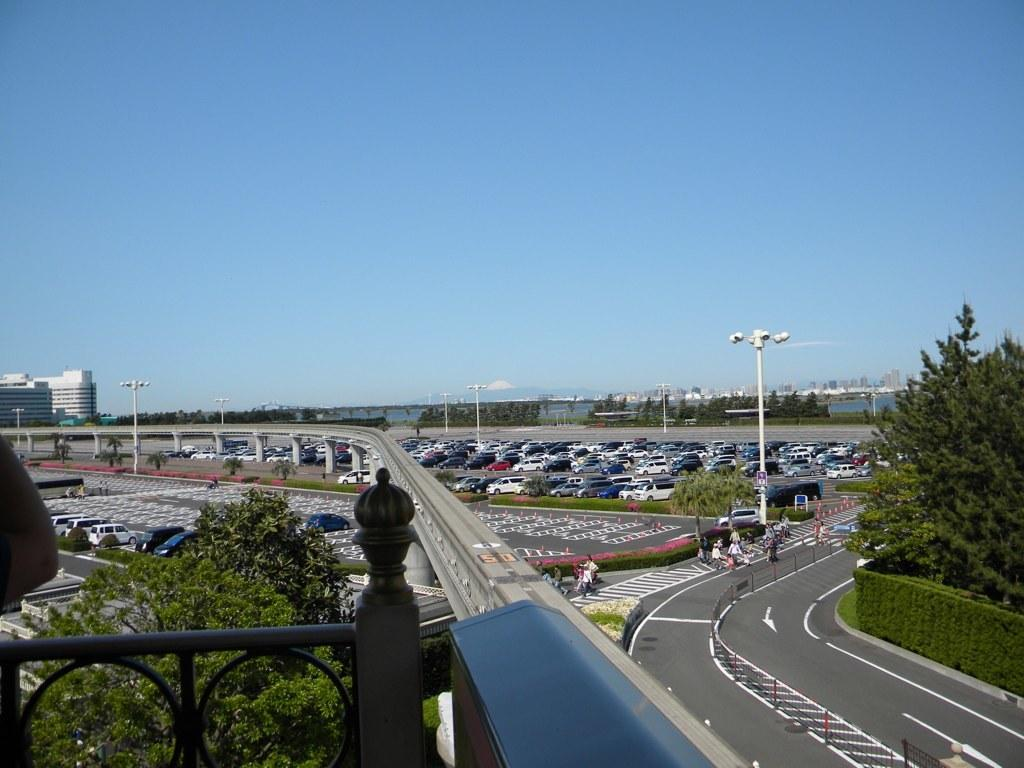What is located in the foreground of the image? In the foreground of the image, there is a railing, a bridge, and trees. What can be seen in the background of the image? In the background of the image, there are parking slots and vehicles, a road, trees, plants, the sky, and a building. Can you describe the type of transportation visible in the image? Vehicles are visible in the parking slots in the background of the image. What type of natural environment is present in the image? Trees and plants are present in both the foreground and background of the image. What type of dinner is being served in the image? There is no dinner present in the image; it features a bridge, railing, trees, vehicles, and a building. How does the beginner learn to swim in the image? There is no swimming or learning activity depicted in the image. 